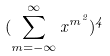Convert formula to latex. <formula><loc_0><loc_0><loc_500><loc_500>( \sum _ { m = - \infty } ^ { \infty } x ^ { m ^ { 2 } } ) ^ { 4 }</formula> 